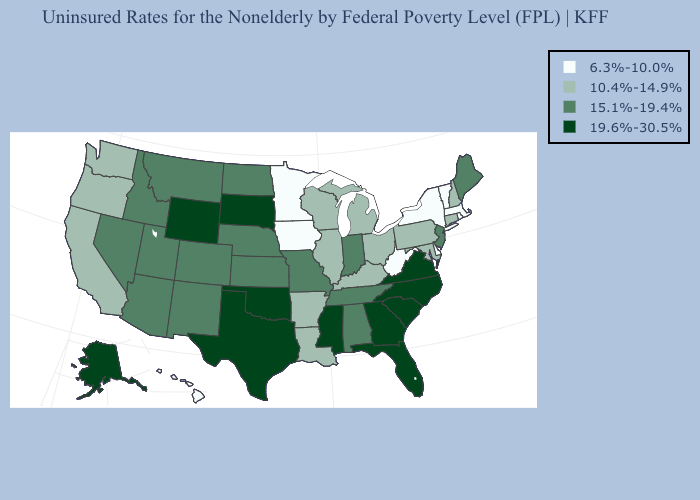Does the first symbol in the legend represent the smallest category?
Concise answer only. Yes. Which states have the lowest value in the USA?
Be succinct. Delaware, Hawaii, Iowa, Massachusetts, Minnesota, New York, Rhode Island, Vermont, West Virginia. Name the states that have a value in the range 10.4%-14.9%?
Answer briefly. Arkansas, California, Connecticut, Illinois, Kentucky, Louisiana, Maryland, Michigan, New Hampshire, Ohio, Oregon, Pennsylvania, Washington, Wisconsin. What is the lowest value in the MidWest?
Keep it brief. 6.3%-10.0%. What is the highest value in the Northeast ?
Be succinct. 15.1%-19.4%. Name the states that have a value in the range 6.3%-10.0%?
Write a very short answer. Delaware, Hawaii, Iowa, Massachusetts, Minnesota, New York, Rhode Island, Vermont, West Virginia. Among the states that border Indiana , which have the highest value?
Be succinct. Illinois, Kentucky, Michigan, Ohio. What is the highest value in states that border Vermont?
Be succinct. 10.4%-14.9%. Name the states that have a value in the range 6.3%-10.0%?
Be succinct. Delaware, Hawaii, Iowa, Massachusetts, Minnesota, New York, Rhode Island, Vermont, West Virginia. Does the map have missing data?
Short answer required. No. What is the value of West Virginia?
Answer briefly. 6.3%-10.0%. Among the states that border Vermont , does New York have the lowest value?
Quick response, please. Yes. Does Wyoming have the lowest value in the USA?
Keep it brief. No. Does the first symbol in the legend represent the smallest category?
Keep it brief. Yes. 